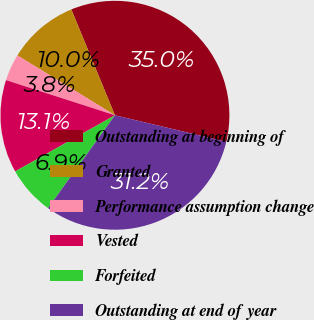Convert chart to OTSL. <chart><loc_0><loc_0><loc_500><loc_500><pie_chart><fcel>Outstanding at beginning of<fcel>Granted<fcel>Performance assumption change<fcel>Vested<fcel>Forfeited<fcel>Outstanding at end of year<nl><fcel>34.95%<fcel>10.02%<fcel>3.79%<fcel>13.13%<fcel>6.9%<fcel>31.21%<nl></chart> 